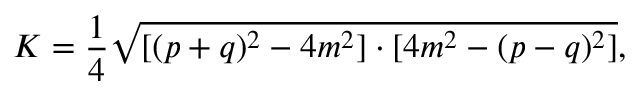Convert formula to latex. <formula><loc_0><loc_0><loc_500><loc_500>K = { \frac { 1 } { 4 } } { \sqrt { [ ( p + q ) ^ { 2 } - 4 m ^ { 2 } ] \cdot [ 4 m ^ { 2 } - ( p - q ) ^ { 2 } ] } } ,</formula> 